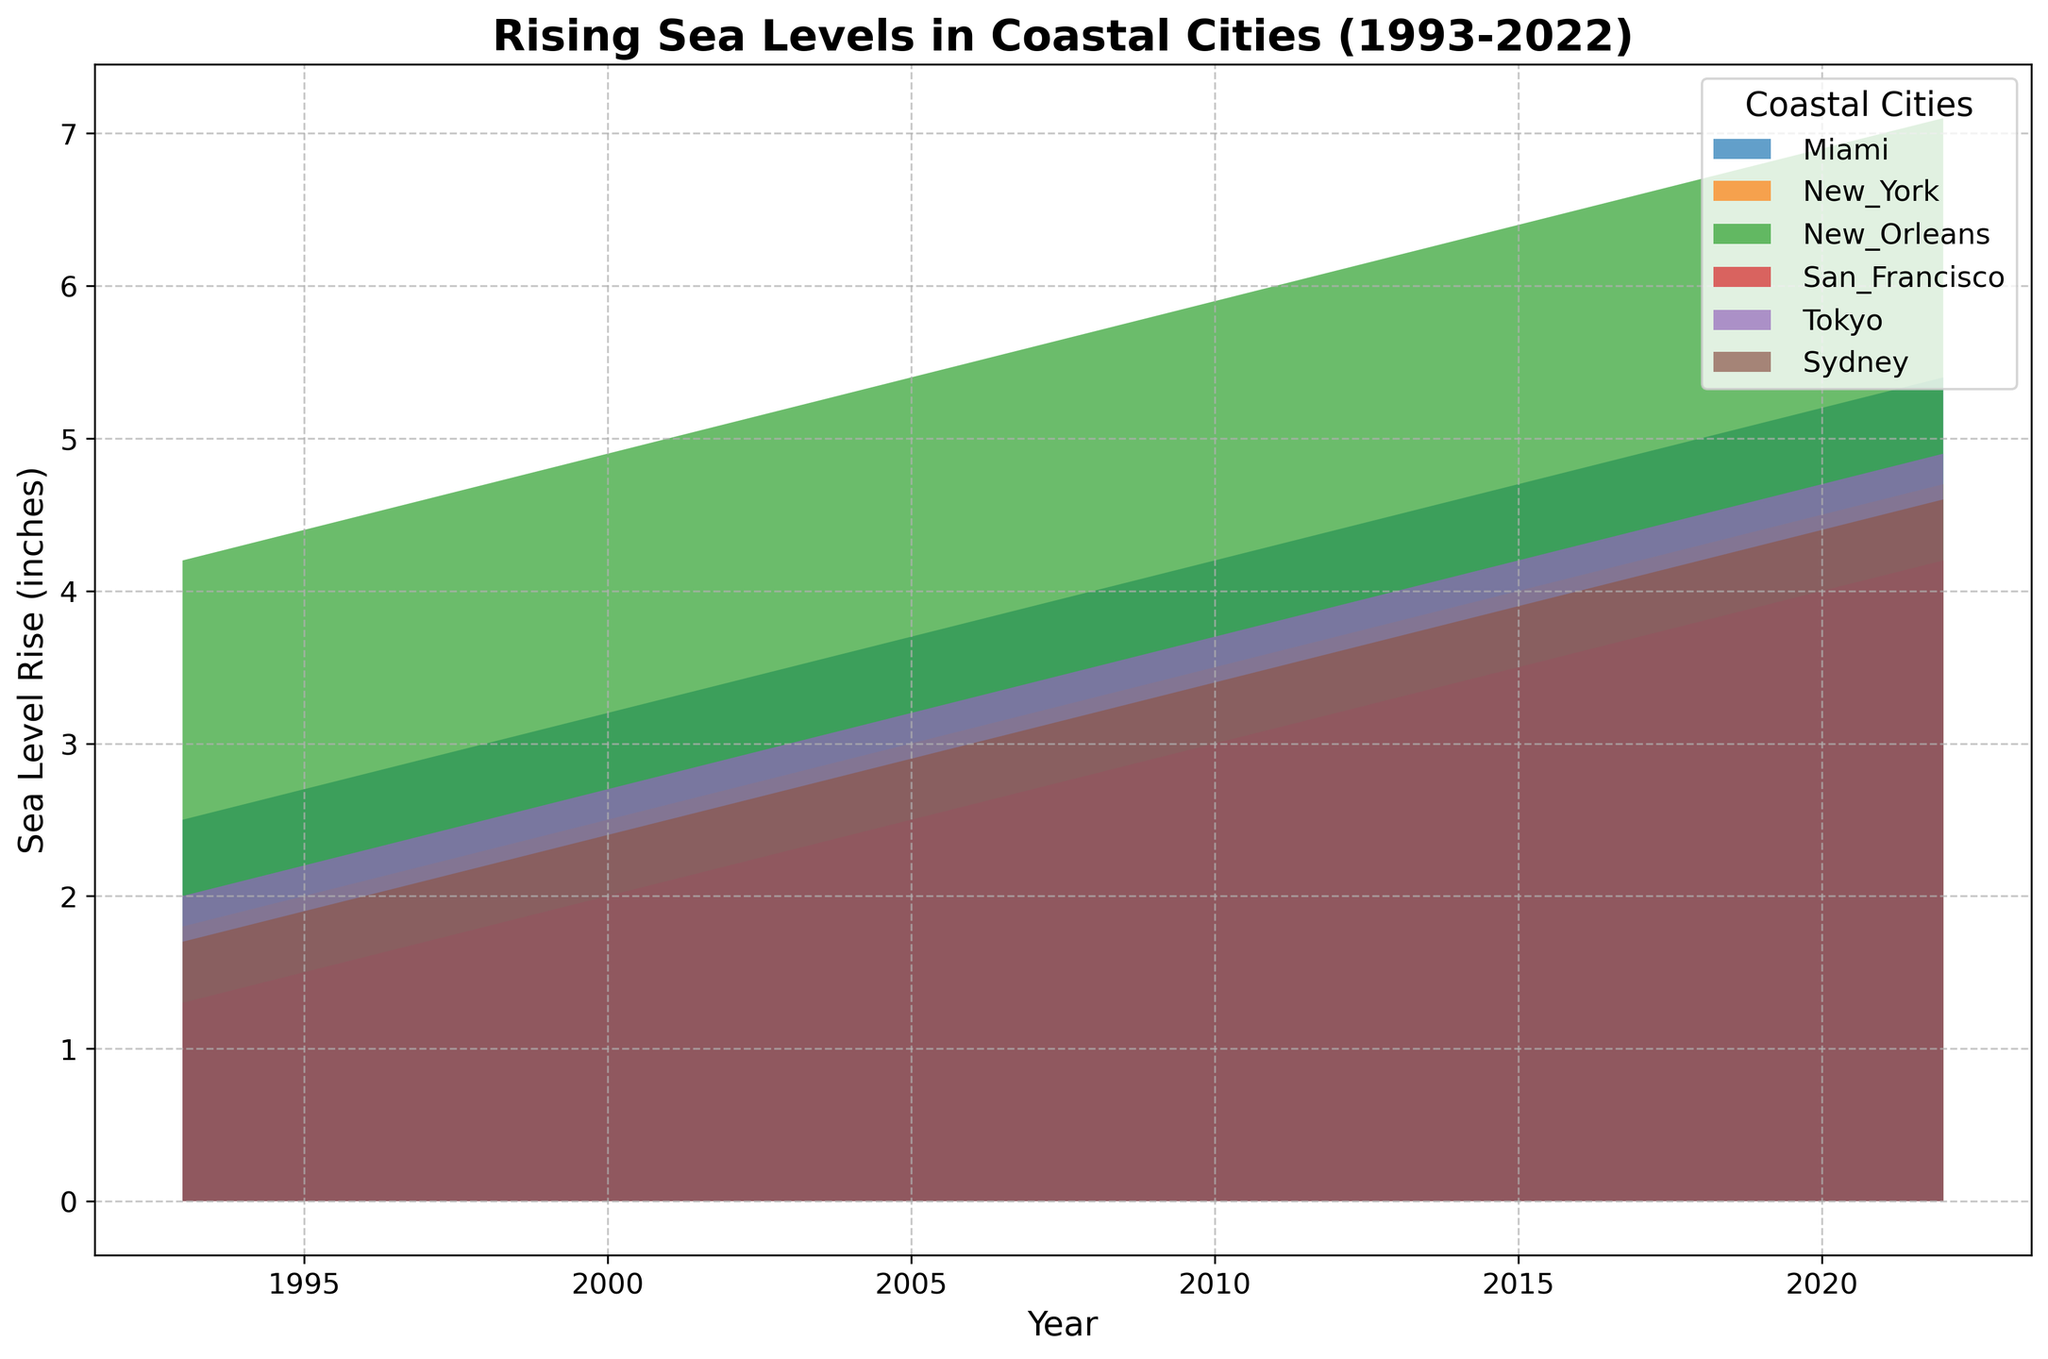How have the sea levels in Miami changed over the past 30 years? By examining the chart, it is evident that the sea levels in Miami have shown a consistent rising trend from 2.5 inches in 1993 to 5.4 inches in 2022.
Answer: risen from 2.5 to 5.4 inches Which coastal city experienced the highest rise in sea levels by 2022? Observing the chart, New Orleans shows the highest sea level rise reaching 7.1 inches in 2022.
Answer: New Orleans What's the approximate difference in sea level rise between Tokyo and Sydney in 2022? From the chart, Tokyo's sea level rise is around 4.9 inches, and Sydney's is roughly 4.6 inches in 2022. Subtracting these values, the difference is 4.9 - 4.6 = 0.3 inches.
Answer: 0.3 inches Between New York and San Francisco, which city had a more significant increase in sea levels from 1993 to 2022? Analyzing the chart, New York's levels rose from 1.8 to 4.7 inches, a 2.9-inch increase, while San Francisco's levels rose from 1.3 to 4.2 inches, a 2.9-inch increase.
Answer: equal increase Which year shows the most rapid increase in sea levels for Miami? Looking at the chart’s slope, the period from 1998 to 1999 for Miami has a noticeable steep rise, indicating the most rapid increase.
Answer: 1998-1999 Cumulatively, how much have sea levels risen in New Orleans from 1993 to 2022? According to the chart, New Orleans saw levels rise from 4.2 inches in 1993 to 7.1 inches in 2022. The cumulative rise is 7.1 - 4.2 = 2.9 inches.
Answer: 2.9 inches What is the average sea level rise in Sydney over the 30-year period? Sydney's levels rise from 1.7 to 4.6 inches over 30 years. The average rise each year can be calculated by (4.6 - 1.7)/30 = 0.0967 inches/year. Multiplying by 30 gives an average rise of approximately 2.9 inches overall.
Answer: 2.9 inches Which city had the least growth in sea levels in the year 2000? From the chart in 2000, San Francisco’s level is comparatively lower at 2.0 inches.
Answer: San Francisco How does the pattern of sea level rise in Tokyo compare to that in New Orleans? Comparing the chart, Tokyo shows a steady but moderate rise, whereas New Orleans shows a higher starting point and a more significant overall increase, reaching higher final values.
Answer: Tokyo: steady rise; New Orleans: higher increase 